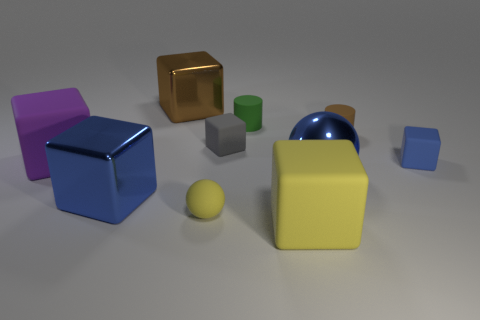What is the shape of the big blue metal object that is on the right side of the gray block?
Provide a succinct answer. Sphere. Does the large object that is behind the small gray object have the same color as the large rubber cube that is on the left side of the tiny gray thing?
Keep it short and to the point. No. The cube that is the same color as the tiny sphere is what size?
Provide a short and direct response. Large. Are any brown matte spheres visible?
Offer a very short reply. No. What shape is the brown thing on the left side of the large blue thing that is behind the large blue metallic thing that is on the left side of the green thing?
Keep it short and to the point. Cube. What number of small gray rubber blocks are in front of the purple object?
Your answer should be very brief. 0. Do the yellow object in front of the tiny sphere and the gray cube have the same material?
Offer a terse response. Yes. What number of other things are the same shape as the green object?
Make the answer very short. 1. There is a tiny rubber cylinder that is on the left side of the blue metal thing that is right of the green thing; what number of small gray rubber blocks are behind it?
Provide a succinct answer. 0. There is a big matte object that is on the right side of the tiny yellow ball; what color is it?
Offer a very short reply. Yellow. 